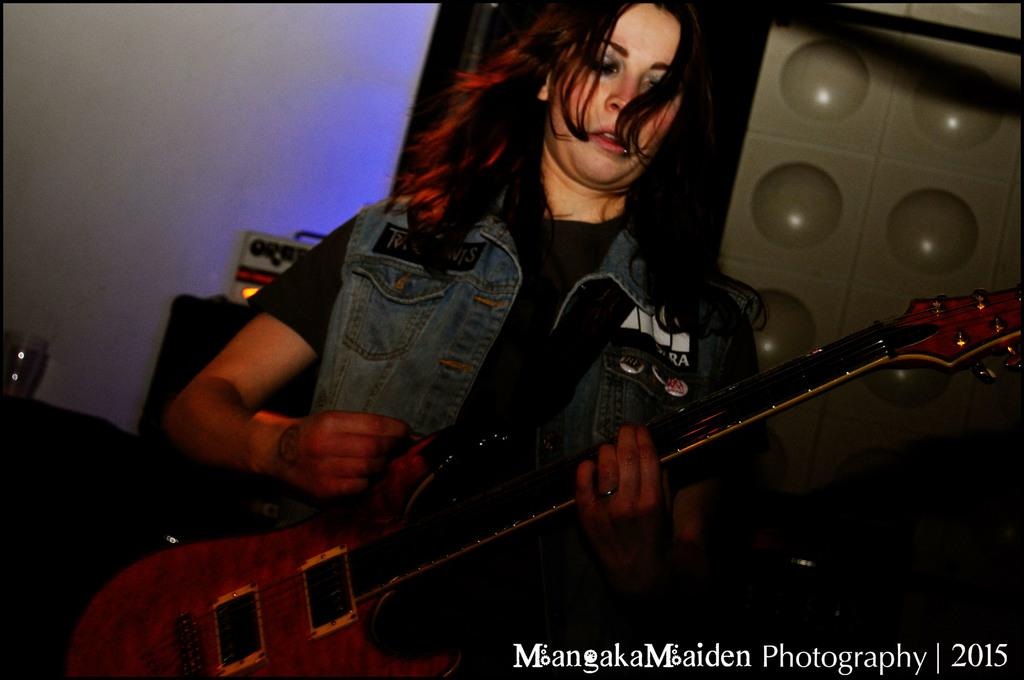Who is the main subject in the image? There is a woman in the image. What is the woman doing in the image? The woman is playing a guitar. What type of tent can be seen in the background of the image? There is no tent present in the image; it only features a woman playing a guitar. 